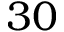Convert formula to latex. <formula><loc_0><loc_0><loc_500><loc_500>3 0</formula> 